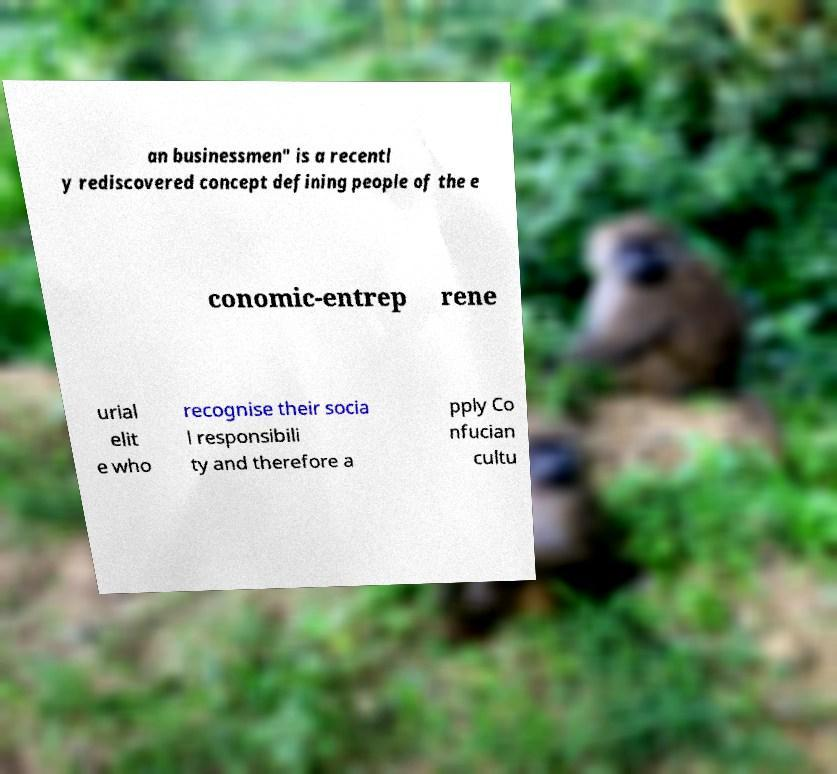Could you assist in decoding the text presented in this image and type it out clearly? an businessmen" is a recentl y rediscovered concept defining people of the e conomic-entrep rene urial elit e who recognise their socia l responsibili ty and therefore a pply Co nfucian cultu 